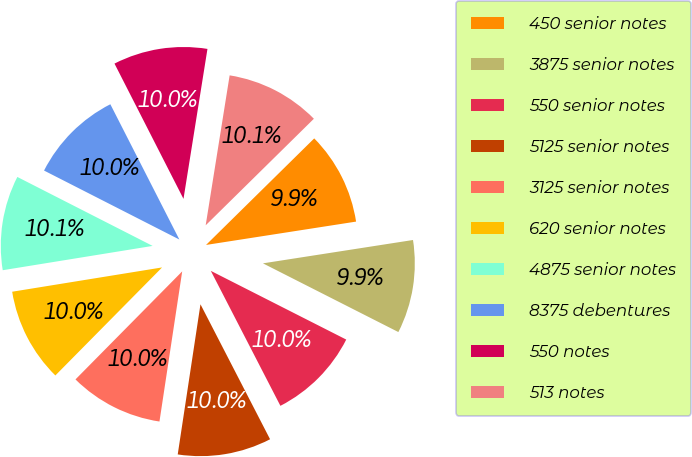Convert chart to OTSL. <chart><loc_0><loc_0><loc_500><loc_500><pie_chart><fcel>450 senior notes<fcel>3875 senior notes<fcel>550 senior notes<fcel>5125 senior notes<fcel>3125 senior notes<fcel>620 senior notes<fcel>4875 senior notes<fcel>8375 debentures<fcel>550 notes<fcel>513 notes<nl><fcel>9.92%<fcel>9.93%<fcel>9.95%<fcel>9.97%<fcel>10.01%<fcel>10.04%<fcel>10.06%<fcel>9.99%<fcel>10.03%<fcel>10.1%<nl></chart> 